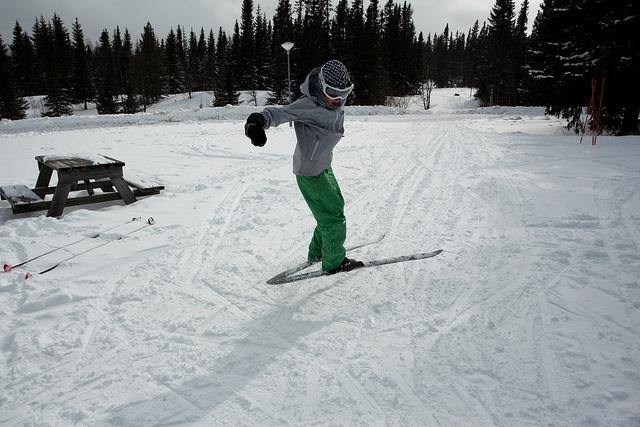Is there a bench?
Give a very brief answer. Yes. Is there a night light?
Be succinct. No. Is he spinning on purpose?
Concise answer only. Yes. 